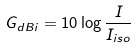<formula> <loc_0><loc_0><loc_500><loc_500>G _ { d B i } = 1 0 \log { \frac { I } { I _ { i s o } } }</formula> 